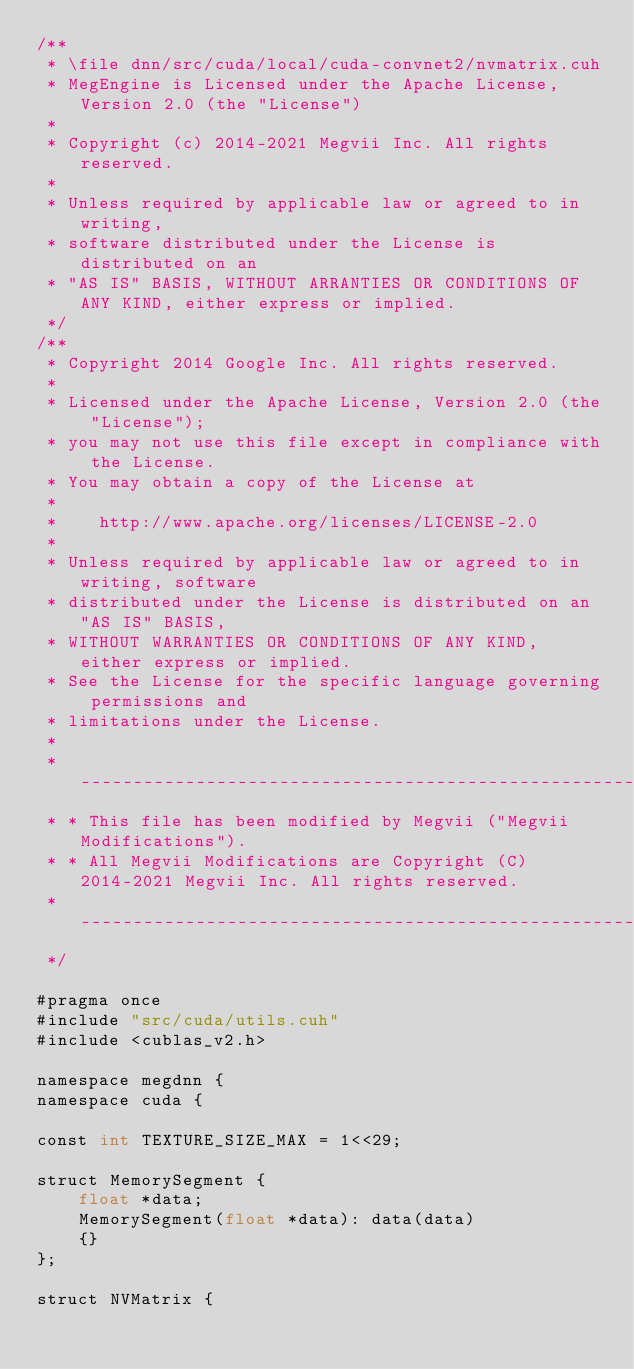Convert code to text. <code><loc_0><loc_0><loc_500><loc_500><_Cuda_>/**
 * \file dnn/src/cuda/local/cuda-convnet2/nvmatrix.cuh
 * MegEngine is Licensed under the Apache License, Version 2.0 (the "License")
 *
 * Copyright (c) 2014-2021 Megvii Inc. All rights reserved.
 *
 * Unless required by applicable law or agreed to in writing,
 * software distributed under the License is distributed on an
 * "AS IS" BASIS, WITHOUT ARRANTIES OR CONDITIONS OF ANY KIND, either express or implied.
 */
/**
 * Copyright 2014 Google Inc. All rights reserved.
 *
 * Licensed under the Apache License, Version 2.0 (the "License");
 * you may not use this file except in compliance with the License.
 * You may obtain a copy of the License at
 *
 *    http://www.apache.org/licenses/LICENSE-2.0
 *
 * Unless required by applicable law or agreed to in writing, software
 * distributed under the License is distributed on an "AS IS" BASIS,
 * WITHOUT WARRANTIES OR CONDITIONS OF ANY KIND, either express or implied.
 * See the License for the specific language governing permissions and
 * limitations under the License.
 *
 * --------------------------------------------------------------------------
 * * This file has been modified by Megvii ("Megvii Modifications").
 * * All Megvii Modifications are Copyright (C) 2014-2021 Megvii Inc. All rights reserved.
 * --------------------------------------------------------------------------
 */

#pragma once
#include "src/cuda/utils.cuh"
#include <cublas_v2.h>

namespace megdnn {
namespace cuda {

const int TEXTURE_SIZE_MAX = 1<<29;

struct MemorySegment {
    float *data;
    MemorySegment(float *data): data(data)
    {}
};

struct NVMatrix {</code> 